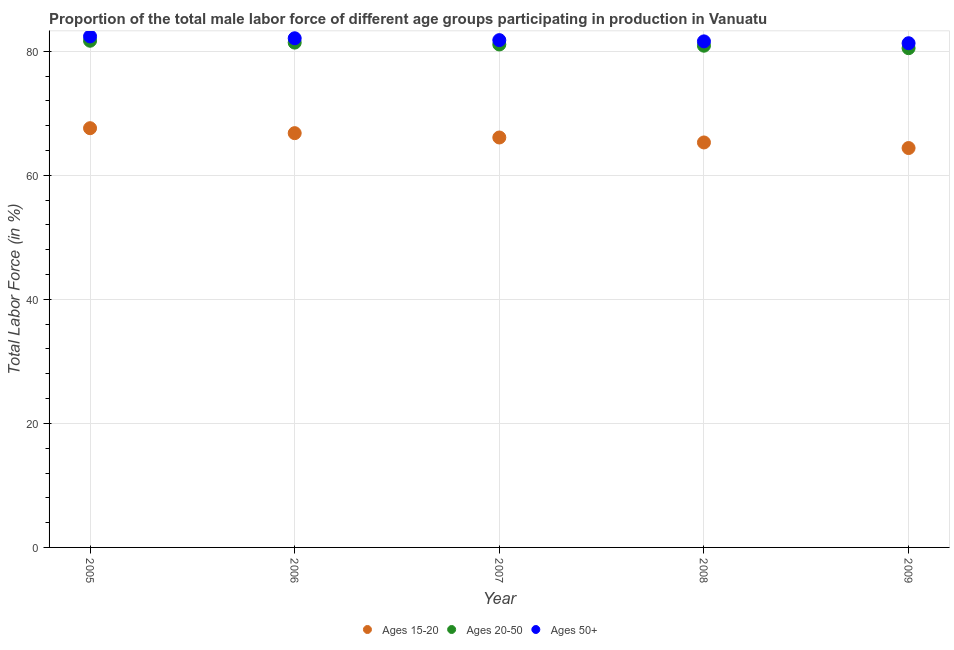How many different coloured dotlines are there?
Make the answer very short. 3. Is the number of dotlines equal to the number of legend labels?
Keep it short and to the point. Yes. What is the percentage of male labor force above age 50 in 2009?
Your response must be concise. 81.3. Across all years, what is the maximum percentage of male labor force within the age group 20-50?
Provide a short and direct response. 81.7. Across all years, what is the minimum percentage of male labor force above age 50?
Provide a short and direct response. 81.3. In which year was the percentage of male labor force above age 50 minimum?
Your response must be concise. 2009. What is the total percentage of male labor force within the age group 15-20 in the graph?
Keep it short and to the point. 330.2. What is the difference between the percentage of male labor force above age 50 in 2007 and that in 2008?
Your answer should be compact. 0.2. What is the difference between the percentage of male labor force within the age group 15-20 in 2006 and the percentage of male labor force above age 50 in 2005?
Offer a terse response. -15.6. What is the average percentage of male labor force above age 50 per year?
Offer a very short reply. 81.84. In the year 2009, what is the difference between the percentage of male labor force within the age group 20-50 and percentage of male labor force within the age group 15-20?
Provide a succinct answer. 16.1. What is the ratio of the percentage of male labor force above age 50 in 2008 to that in 2009?
Provide a succinct answer. 1. Is the difference between the percentage of male labor force within the age group 20-50 in 2008 and 2009 greater than the difference between the percentage of male labor force within the age group 15-20 in 2008 and 2009?
Make the answer very short. No. What is the difference between the highest and the second highest percentage of male labor force within the age group 20-50?
Make the answer very short. 0.3. What is the difference between the highest and the lowest percentage of male labor force within the age group 15-20?
Keep it short and to the point. 3.2. In how many years, is the percentage of male labor force within the age group 15-20 greater than the average percentage of male labor force within the age group 15-20 taken over all years?
Your answer should be very brief. 3. Is the percentage of male labor force within the age group 15-20 strictly greater than the percentage of male labor force within the age group 20-50 over the years?
Keep it short and to the point. No. Is the percentage of male labor force above age 50 strictly less than the percentage of male labor force within the age group 20-50 over the years?
Keep it short and to the point. No. Are the values on the major ticks of Y-axis written in scientific E-notation?
Offer a very short reply. No. How many legend labels are there?
Your answer should be very brief. 3. How are the legend labels stacked?
Give a very brief answer. Horizontal. What is the title of the graph?
Provide a succinct answer. Proportion of the total male labor force of different age groups participating in production in Vanuatu. Does "New Zealand" appear as one of the legend labels in the graph?
Offer a very short reply. No. What is the label or title of the X-axis?
Your response must be concise. Year. What is the Total Labor Force (in %) in Ages 15-20 in 2005?
Give a very brief answer. 67.6. What is the Total Labor Force (in %) of Ages 20-50 in 2005?
Provide a succinct answer. 81.7. What is the Total Labor Force (in %) of Ages 50+ in 2005?
Make the answer very short. 82.4. What is the Total Labor Force (in %) of Ages 15-20 in 2006?
Your response must be concise. 66.8. What is the Total Labor Force (in %) of Ages 20-50 in 2006?
Your response must be concise. 81.4. What is the Total Labor Force (in %) of Ages 50+ in 2006?
Give a very brief answer. 82.1. What is the Total Labor Force (in %) of Ages 15-20 in 2007?
Ensure brevity in your answer.  66.1. What is the Total Labor Force (in %) in Ages 20-50 in 2007?
Make the answer very short. 81.1. What is the Total Labor Force (in %) of Ages 50+ in 2007?
Ensure brevity in your answer.  81.8. What is the Total Labor Force (in %) in Ages 15-20 in 2008?
Offer a terse response. 65.3. What is the Total Labor Force (in %) in Ages 20-50 in 2008?
Offer a terse response. 80.9. What is the Total Labor Force (in %) in Ages 50+ in 2008?
Ensure brevity in your answer.  81.6. What is the Total Labor Force (in %) in Ages 15-20 in 2009?
Keep it short and to the point. 64.4. What is the Total Labor Force (in %) of Ages 20-50 in 2009?
Ensure brevity in your answer.  80.5. What is the Total Labor Force (in %) in Ages 50+ in 2009?
Offer a terse response. 81.3. Across all years, what is the maximum Total Labor Force (in %) of Ages 15-20?
Keep it short and to the point. 67.6. Across all years, what is the maximum Total Labor Force (in %) in Ages 20-50?
Offer a terse response. 81.7. Across all years, what is the maximum Total Labor Force (in %) of Ages 50+?
Your response must be concise. 82.4. Across all years, what is the minimum Total Labor Force (in %) of Ages 15-20?
Your answer should be very brief. 64.4. Across all years, what is the minimum Total Labor Force (in %) of Ages 20-50?
Your answer should be very brief. 80.5. Across all years, what is the minimum Total Labor Force (in %) in Ages 50+?
Keep it short and to the point. 81.3. What is the total Total Labor Force (in %) of Ages 15-20 in the graph?
Provide a succinct answer. 330.2. What is the total Total Labor Force (in %) of Ages 20-50 in the graph?
Provide a succinct answer. 405.6. What is the total Total Labor Force (in %) in Ages 50+ in the graph?
Provide a short and direct response. 409.2. What is the difference between the Total Labor Force (in %) in Ages 15-20 in 2005 and that in 2007?
Offer a very short reply. 1.5. What is the difference between the Total Labor Force (in %) in Ages 20-50 in 2005 and that in 2007?
Offer a terse response. 0.6. What is the difference between the Total Labor Force (in %) in Ages 50+ in 2005 and that in 2007?
Provide a short and direct response. 0.6. What is the difference between the Total Labor Force (in %) of Ages 15-20 in 2005 and that in 2008?
Make the answer very short. 2.3. What is the difference between the Total Labor Force (in %) in Ages 50+ in 2006 and that in 2007?
Your answer should be compact. 0.3. What is the difference between the Total Labor Force (in %) of Ages 20-50 in 2006 and that in 2009?
Offer a terse response. 0.9. What is the difference between the Total Labor Force (in %) in Ages 50+ in 2006 and that in 2009?
Provide a succinct answer. 0.8. What is the difference between the Total Labor Force (in %) in Ages 20-50 in 2007 and that in 2009?
Your response must be concise. 0.6. What is the difference between the Total Labor Force (in %) of Ages 50+ in 2008 and that in 2009?
Your answer should be compact. 0.3. What is the difference between the Total Labor Force (in %) in Ages 15-20 in 2005 and the Total Labor Force (in %) in Ages 50+ in 2006?
Offer a very short reply. -14.5. What is the difference between the Total Labor Force (in %) of Ages 15-20 in 2005 and the Total Labor Force (in %) of Ages 20-50 in 2007?
Keep it short and to the point. -13.5. What is the difference between the Total Labor Force (in %) in Ages 15-20 in 2005 and the Total Labor Force (in %) in Ages 50+ in 2007?
Provide a short and direct response. -14.2. What is the difference between the Total Labor Force (in %) in Ages 15-20 in 2005 and the Total Labor Force (in %) in Ages 20-50 in 2008?
Provide a short and direct response. -13.3. What is the difference between the Total Labor Force (in %) of Ages 15-20 in 2005 and the Total Labor Force (in %) of Ages 50+ in 2009?
Offer a very short reply. -13.7. What is the difference between the Total Labor Force (in %) of Ages 20-50 in 2005 and the Total Labor Force (in %) of Ages 50+ in 2009?
Provide a succinct answer. 0.4. What is the difference between the Total Labor Force (in %) of Ages 15-20 in 2006 and the Total Labor Force (in %) of Ages 20-50 in 2007?
Your response must be concise. -14.3. What is the difference between the Total Labor Force (in %) of Ages 15-20 in 2006 and the Total Labor Force (in %) of Ages 20-50 in 2008?
Make the answer very short. -14.1. What is the difference between the Total Labor Force (in %) in Ages 15-20 in 2006 and the Total Labor Force (in %) in Ages 50+ in 2008?
Offer a terse response. -14.8. What is the difference between the Total Labor Force (in %) of Ages 15-20 in 2006 and the Total Labor Force (in %) of Ages 20-50 in 2009?
Your answer should be compact. -13.7. What is the difference between the Total Labor Force (in %) in Ages 15-20 in 2007 and the Total Labor Force (in %) in Ages 20-50 in 2008?
Make the answer very short. -14.8. What is the difference between the Total Labor Force (in %) of Ages 15-20 in 2007 and the Total Labor Force (in %) of Ages 50+ in 2008?
Make the answer very short. -15.5. What is the difference between the Total Labor Force (in %) of Ages 15-20 in 2007 and the Total Labor Force (in %) of Ages 20-50 in 2009?
Offer a terse response. -14.4. What is the difference between the Total Labor Force (in %) of Ages 15-20 in 2007 and the Total Labor Force (in %) of Ages 50+ in 2009?
Ensure brevity in your answer.  -15.2. What is the difference between the Total Labor Force (in %) in Ages 15-20 in 2008 and the Total Labor Force (in %) in Ages 20-50 in 2009?
Offer a terse response. -15.2. What is the difference between the Total Labor Force (in %) in Ages 15-20 in 2008 and the Total Labor Force (in %) in Ages 50+ in 2009?
Provide a succinct answer. -16. What is the difference between the Total Labor Force (in %) of Ages 20-50 in 2008 and the Total Labor Force (in %) of Ages 50+ in 2009?
Your answer should be very brief. -0.4. What is the average Total Labor Force (in %) in Ages 15-20 per year?
Offer a terse response. 66.04. What is the average Total Labor Force (in %) in Ages 20-50 per year?
Offer a terse response. 81.12. What is the average Total Labor Force (in %) of Ages 50+ per year?
Keep it short and to the point. 81.84. In the year 2005, what is the difference between the Total Labor Force (in %) in Ages 15-20 and Total Labor Force (in %) in Ages 20-50?
Your answer should be compact. -14.1. In the year 2005, what is the difference between the Total Labor Force (in %) of Ages 15-20 and Total Labor Force (in %) of Ages 50+?
Offer a terse response. -14.8. In the year 2005, what is the difference between the Total Labor Force (in %) of Ages 20-50 and Total Labor Force (in %) of Ages 50+?
Your response must be concise. -0.7. In the year 2006, what is the difference between the Total Labor Force (in %) in Ages 15-20 and Total Labor Force (in %) in Ages 20-50?
Keep it short and to the point. -14.6. In the year 2006, what is the difference between the Total Labor Force (in %) in Ages 15-20 and Total Labor Force (in %) in Ages 50+?
Offer a very short reply. -15.3. In the year 2007, what is the difference between the Total Labor Force (in %) in Ages 15-20 and Total Labor Force (in %) in Ages 20-50?
Your answer should be compact. -15. In the year 2007, what is the difference between the Total Labor Force (in %) of Ages 15-20 and Total Labor Force (in %) of Ages 50+?
Your answer should be very brief. -15.7. In the year 2007, what is the difference between the Total Labor Force (in %) of Ages 20-50 and Total Labor Force (in %) of Ages 50+?
Offer a terse response. -0.7. In the year 2008, what is the difference between the Total Labor Force (in %) in Ages 15-20 and Total Labor Force (in %) in Ages 20-50?
Provide a succinct answer. -15.6. In the year 2008, what is the difference between the Total Labor Force (in %) of Ages 15-20 and Total Labor Force (in %) of Ages 50+?
Your answer should be compact. -16.3. In the year 2009, what is the difference between the Total Labor Force (in %) in Ages 15-20 and Total Labor Force (in %) in Ages 20-50?
Make the answer very short. -16.1. In the year 2009, what is the difference between the Total Labor Force (in %) in Ages 15-20 and Total Labor Force (in %) in Ages 50+?
Provide a short and direct response. -16.9. In the year 2009, what is the difference between the Total Labor Force (in %) in Ages 20-50 and Total Labor Force (in %) in Ages 50+?
Your answer should be compact. -0.8. What is the ratio of the Total Labor Force (in %) in Ages 20-50 in 2005 to that in 2006?
Keep it short and to the point. 1. What is the ratio of the Total Labor Force (in %) of Ages 50+ in 2005 to that in 2006?
Provide a succinct answer. 1. What is the ratio of the Total Labor Force (in %) of Ages 15-20 in 2005 to that in 2007?
Ensure brevity in your answer.  1.02. What is the ratio of the Total Labor Force (in %) in Ages 20-50 in 2005 to that in 2007?
Provide a short and direct response. 1.01. What is the ratio of the Total Labor Force (in %) of Ages 50+ in 2005 to that in 2007?
Keep it short and to the point. 1.01. What is the ratio of the Total Labor Force (in %) of Ages 15-20 in 2005 to that in 2008?
Make the answer very short. 1.04. What is the ratio of the Total Labor Force (in %) of Ages 20-50 in 2005 to that in 2008?
Your response must be concise. 1.01. What is the ratio of the Total Labor Force (in %) of Ages 50+ in 2005 to that in 2008?
Offer a terse response. 1.01. What is the ratio of the Total Labor Force (in %) in Ages 15-20 in 2005 to that in 2009?
Your answer should be very brief. 1.05. What is the ratio of the Total Labor Force (in %) of Ages 20-50 in 2005 to that in 2009?
Give a very brief answer. 1.01. What is the ratio of the Total Labor Force (in %) in Ages 50+ in 2005 to that in 2009?
Your answer should be very brief. 1.01. What is the ratio of the Total Labor Force (in %) in Ages 15-20 in 2006 to that in 2007?
Your answer should be very brief. 1.01. What is the ratio of the Total Labor Force (in %) in Ages 20-50 in 2006 to that in 2007?
Provide a short and direct response. 1. What is the ratio of the Total Labor Force (in %) of Ages 50+ in 2006 to that in 2007?
Provide a short and direct response. 1. What is the ratio of the Total Labor Force (in %) of Ages 15-20 in 2006 to that in 2008?
Your answer should be compact. 1.02. What is the ratio of the Total Labor Force (in %) of Ages 20-50 in 2006 to that in 2008?
Your answer should be very brief. 1.01. What is the ratio of the Total Labor Force (in %) in Ages 50+ in 2006 to that in 2008?
Give a very brief answer. 1.01. What is the ratio of the Total Labor Force (in %) of Ages 15-20 in 2006 to that in 2009?
Your response must be concise. 1.04. What is the ratio of the Total Labor Force (in %) in Ages 20-50 in 2006 to that in 2009?
Provide a short and direct response. 1.01. What is the ratio of the Total Labor Force (in %) of Ages 50+ in 2006 to that in 2009?
Keep it short and to the point. 1.01. What is the ratio of the Total Labor Force (in %) of Ages 15-20 in 2007 to that in 2008?
Offer a terse response. 1.01. What is the ratio of the Total Labor Force (in %) of Ages 15-20 in 2007 to that in 2009?
Ensure brevity in your answer.  1.03. What is the ratio of the Total Labor Force (in %) of Ages 20-50 in 2007 to that in 2009?
Your answer should be very brief. 1.01. What is the ratio of the Total Labor Force (in %) of Ages 15-20 in 2008 to that in 2009?
Offer a terse response. 1.01. What is the ratio of the Total Labor Force (in %) in Ages 20-50 in 2008 to that in 2009?
Your answer should be compact. 1. What is the ratio of the Total Labor Force (in %) of Ages 50+ in 2008 to that in 2009?
Keep it short and to the point. 1. What is the difference between the highest and the second highest Total Labor Force (in %) of Ages 15-20?
Your answer should be compact. 0.8. What is the difference between the highest and the second highest Total Labor Force (in %) in Ages 50+?
Keep it short and to the point. 0.3. What is the difference between the highest and the lowest Total Labor Force (in %) in Ages 15-20?
Your response must be concise. 3.2. What is the difference between the highest and the lowest Total Labor Force (in %) of Ages 50+?
Offer a very short reply. 1.1. 